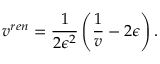<formula> <loc_0><loc_0><loc_500><loc_500>v ^ { r e n } = \frac { 1 } { 2 \epsilon ^ { 2 } } \left ( \frac { 1 } { v } - 2 \epsilon \right ) .</formula> 